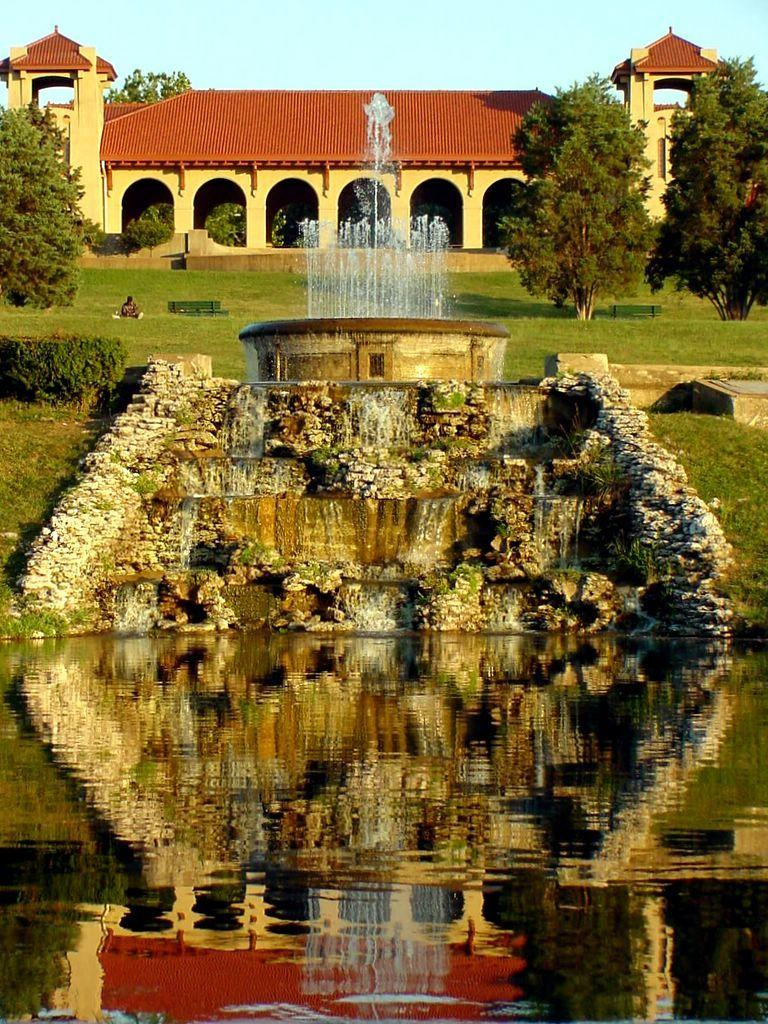What is the main feature in the image? There is a fountain present in the image. What type of vegetation can be seen in the image? There are trees with green leaves in the image. Can you describe the person in the image? A person is sitting in the image. What is the color scheme of the building in the image? The building has cream and red colors in the image. What is the color of the sky in the image? The sky is blue in the image. How many frogs are jumping around the fountain in the image? There are no frogs present in the image; it only features a fountain, trees, a person, a building, and a blue sky. What type of business is being conducted in the image? There is no indication of any business being conducted in the image. 